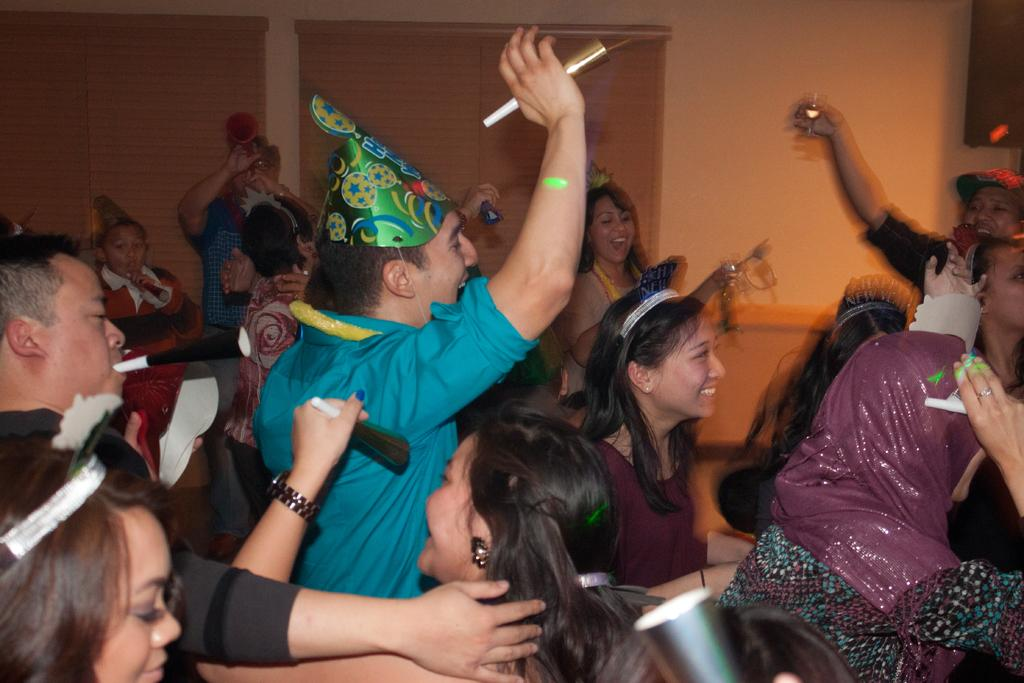How many people are in the image? There is a group of people in the image, but the exact number is not specified. What are the people in the image doing? The people are standing and smiling in the image. What is in front of the group of people? There is a wall in front of the group of people. What type of glove is being used by the people in the image? There is no glove present in the image; the people are simply standing and smiling. 